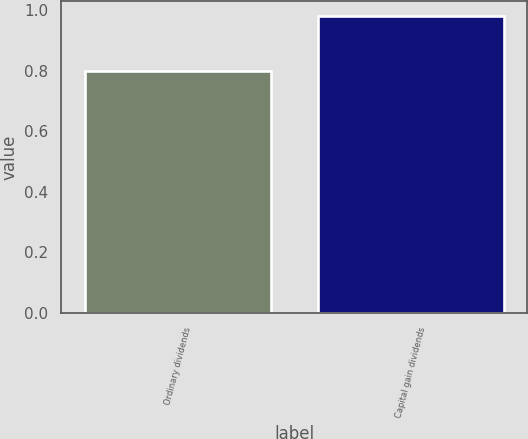<chart> <loc_0><loc_0><loc_500><loc_500><bar_chart><fcel>Ordinary dividends<fcel>Capital gain dividends<nl><fcel>0.8<fcel>0.98<nl></chart> 